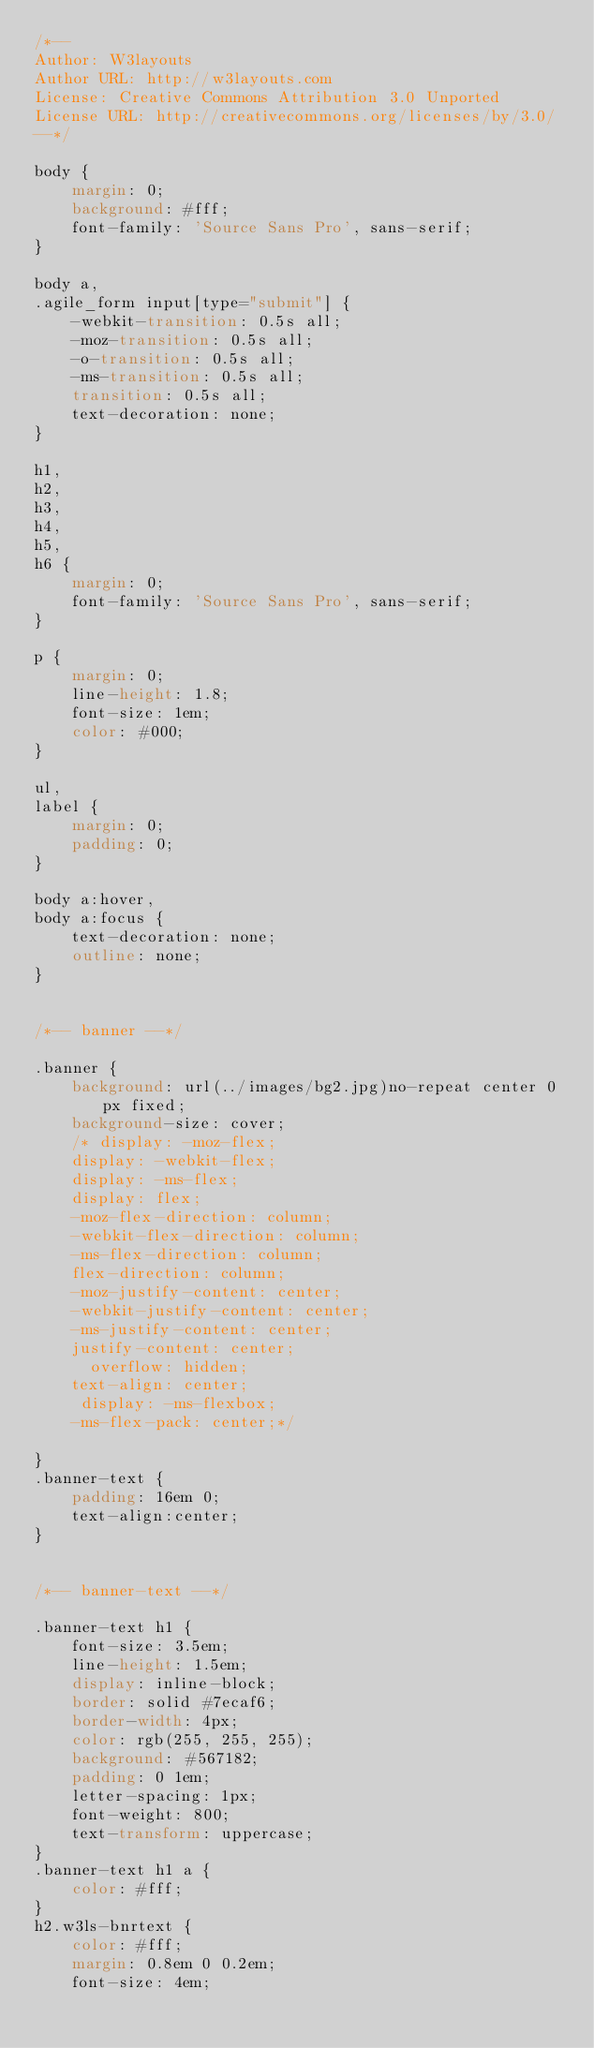<code> <loc_0><loc_0><loc_500><loc_500><_CSS_>/*--
Author: W3layouts
Author URL: http://w3layouts.com
License: Creative Commons Attribution 3.0 Unported
License URL: http://creativecommons.org/licenses/by/3.0/
--*/

body {
    margin: 0;
    background: #fff;
    font-family: 'Source Sans Pro', sans-serif;
}

body a,
.agile_form input[type="submit"] {
    -webkit-transition: 0.5s all;
    -moz-transition: 0.5s all;
    -o-transition: 0.5s all;
    -ms-transition: 0.5s all;
    transition: 0.5s all;
    text-decoration: none;
}

h1,
h2,
h3,
h4,
h5,
h6 {
    margin: 0;
    font-family: 'Source Sans Pro', sans-serif;
}

p {
    margin: 0;
    line-height: 1.8;
    font-size: 1em;
    color: #000;
}

ul,
label {
    margin: 0;
    padding: 0;
}

body a:hover,
body a:focus {
    text-decoration: none;
    outline: none;
}


/*-- banner --*/

.banner {
    background: url(../images/bg2.jpg)no-repeat center 0px fixed;
    background-size: cover;
    /* display: -moz-flex; 
    display: -webkit-flex;
    display: -ms-flex;
    display: flex;
    -moz-flex-direction: column;
    -webkit-flex-direction: column;
    -ms-flex-direction: column;
    flex-direction: column;
    -moz-justify-content: center;
    -webkit-justify-content: center;
    -ms-justify-content: center;
    justify-content: center;
      overflow: hidden;
    text-align: center; 
     display: -ms-flexbox;
    -ms-flex-pack: center;*/
   
}
.banner-text {
    padding: 16em 0;
    text-align:center;
}


/*-- banner-text --*/

.banner-text h1 {
    font-size: 3.5em;
    line-height: 1.5em;
    display: inline-block;
    border: solid #7ecaf6;
    border-width: 4px;
    color: rgb(255, 255, 255);
    background: #567182;
    padding: 0 1em;
    letter-spacing: 1px;
    font-weight: 800;
    text-transform: uppercase;
}
.banner-text h1 a {
    color: #fff;
}
h2.w3ls-bnrtext {
    color: #fff;
    margin: 0.8em 0 0.2em;
    font-size: 4em;</code> 